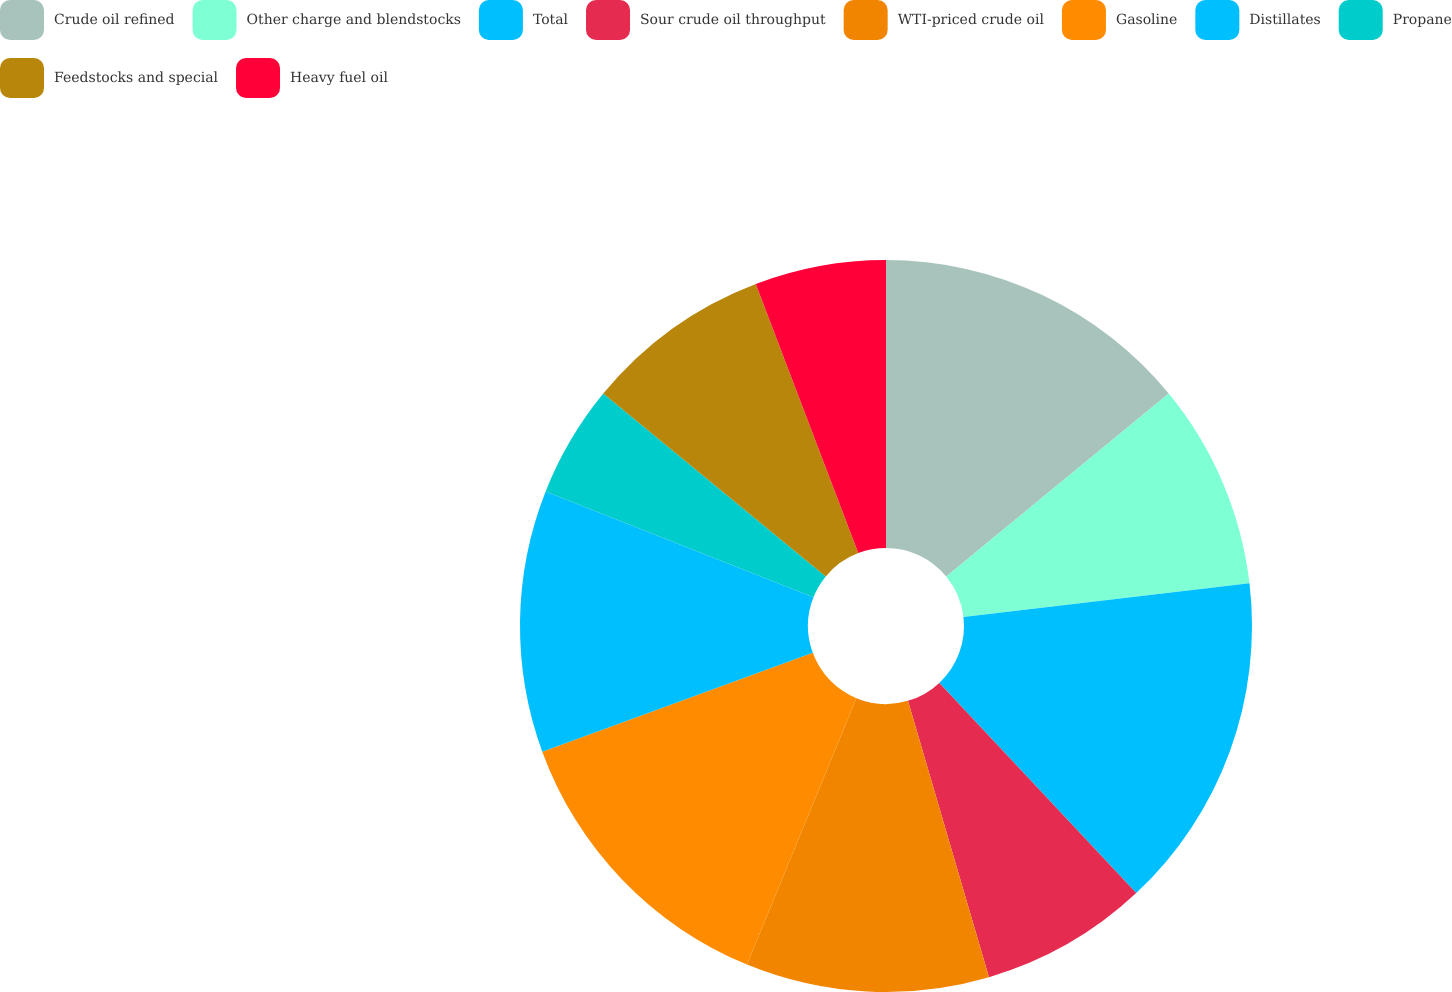<chart> <loc_0><loc_0><loc_500><loc_500><pie_chart><fcel>Crude oil refined<fcel>Other charge and blendstocks<fcel>Total<fcel>Sour crude oil throughput<fcel>WTI-priced crude oil<fcel>Gasoline<fcel>Distillates<fcel>Propane<fcel>Feedstocks and special<fcel>Heavy fuel oil<nl><fcel>14.05%<fcel>9.09%<fcel>14.88%<fcel>7.44%<fcel>10.74%<fcel>13.22%<fcel>11.57%<fcel>4.96%<fcel>8.26%<fcel>5.79%<nl></chart> 